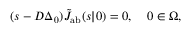Convert formula to latex. <formula><loc_0><loc_0><loc_500><loc_500>( s - D \Delta _ { \ r _ { 0 } } ) \tilde { J } _ { a b } ( s | \ r _ { 0 } ) = 0 , \quad \ r _ { 0 } \in \Omega ,</formula> 